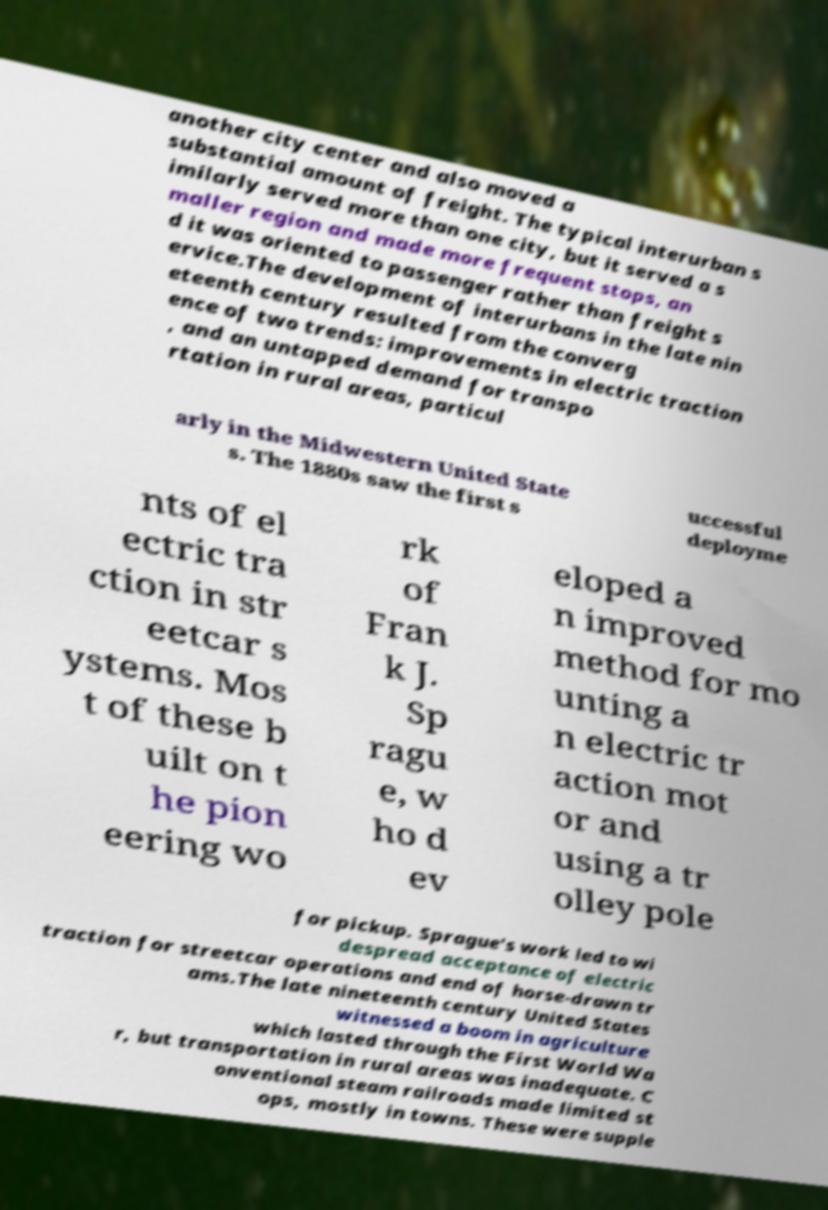Could you assist in decoding the text presented in this image and type it out clearly? another city center and also moved a substantial amount of freight. The typical interurban s imilarly served more than one city, but it served a s maller region and made more frequent stops, an d it was oriented to passenger rather than freight s ervice.The development of interurbans in the late nin eteenth century resulted from the converg ence of two trends: improvements in electric traction , and an untapped demand for transpo rtation in rural areas, particul arly in the Midwestern United State s. The 1880s saw the first s uccessful deployme nts of el ectric tra ction in str eetcar s ystems. Mos t of these b uilt on t he pion eering wo rk of Fran k J. Sp ragu e, w ho d ev eloped a n improved method for mo unting a n electric tr action mot or and using a tr olley pole for pickup. Sprague's work led to wi despread acceptance of electric traction for streetcar operations and end of horse-drawn tr ams.The late nineteenth century United States witnessed a boom in agriculture which lasted through the First World Wa r, but transportation in rural areas was inadequate. C onventional steam railroads made limited st ops, mostly in towns. These were supple 